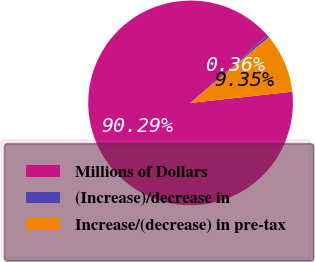Convert chart. <chart><loc_0><loc_0><loc_500><loc_500><pie_chart><fcel>Millions of Dollars<fcel>(Increase)/decrease in<fcel>Increase/(decrease) in pre-tax<nl><fcel>90.29%<fcel>0.36%<fcel>9.35%<nl></chart> 